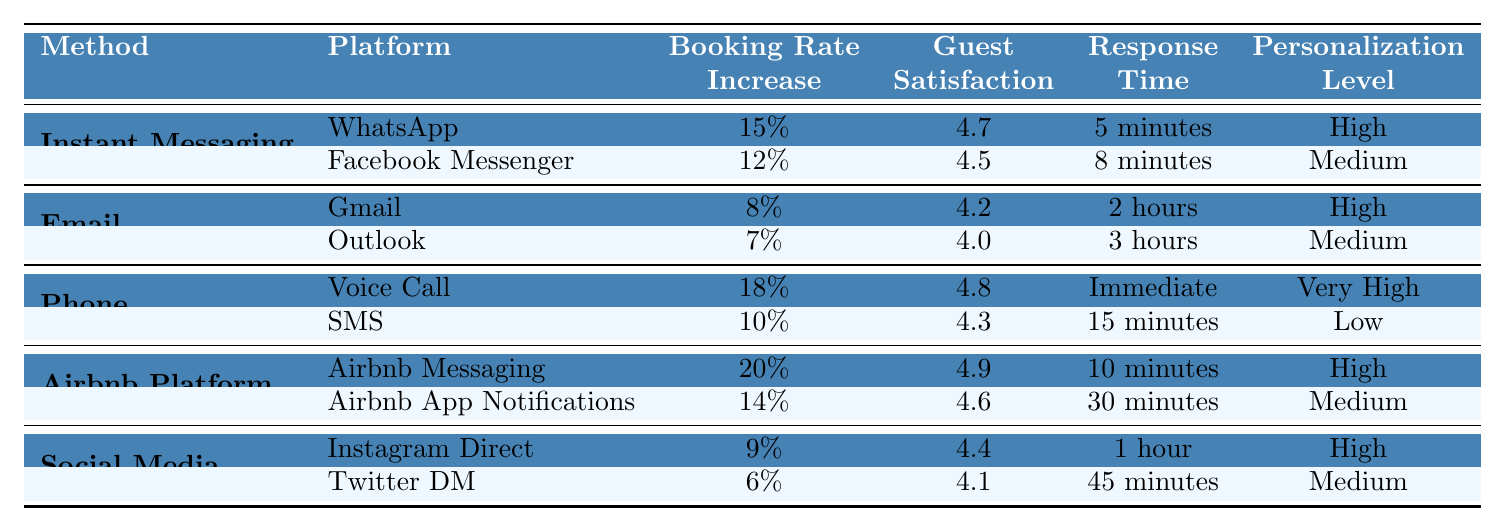What is the booking rate increase for Voice Call? The table lists the booking rate increase for Voice Call under the Phone communication method, which is specified as 18%.
Answer: 18% Which communication method has the highest guest satisfaction score? By examining the guest satisfaction scores for each method, Airbnb Messaging has the highest score of 4.9, making it the top choice.
Answer: Airbnb Messaging What is the average booking rate increase for all communication methods listed? The booking rate increases are: 15%, 12%, 8%, 7%, 18%, 10%, 20%, 14%, 9%, and 6%. Summing these gives 20 + 18 + 15 + 14 + 12 + 10 + 9 + 8 + 7 + 6 = 119. There are 10 values, so the average is 119/10 = 11.9%.
Answer: 11.9% Is the guest satisfaction score for Facebook Messenger higher than that of SMS? Facebook Messenger has a satisfaction score of 4.5, while SMS has a score of 4.3. Since 4.5 is greater than 4.3, the statement is true.
Answer: Yes Which platform under the Airbnb Platform category has the lowest response time? By reviewing the response times for platforms under the Airbnb Platform category, Airbnb Messaging has a response time of 10 minutes, while Airbnb App Notifications has a response time of 30 minutes. Therefore, Airbnb Messaging has the lowest response time.
Answer: Airbnb Messaging How much higher is the booking rate increase for WhatsApp compared to Outlook? WhatsApp has a booking rate increase of 15%, and Outlook has 7%. To find the difference, we calculate 15% - 7% = 8%.
Answer: 8% Is the personalization level for the SMS platform considered high? The table indicates that the personalization level for SMS is categorized as Low, thus the statement is false.
Answer: No What is the combined guest satisfaction score for Email platforms? The guest satisfaction scores for Email platforms are: Gmail (4.2) and Outlook (4.0). Adding these gives 4.2 + 4.0 = 8.2.
Answer: 8.2 Under which communication method is Instagram Direct found, and what is its booking rate increase? Instagram Direct is listed under the Social Media communication method, and it has a booking rate increase of 9%.
Answer: Social Media, 9% What is the relationship between the booking rate increase and response time for Voice Call? The Voice Call has a booking rate increase of 18% and an immediate response time. This suggests a strong positive relationship since immediate responses may correlate with higher booking rates.
Answer: Strong positive relationship 